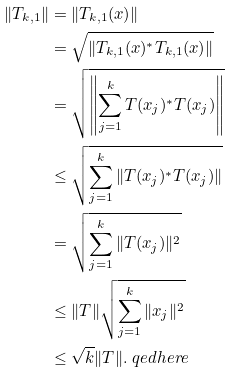Convert formula to latex. <formula><loc_0><loc_0><loc_500><loc_500>\| T _ { k , 1 } \| & = \| T _ { k , 1 } ( x ) \| \\ & = \sqrt { \| T _ { k , 1 } ( x ) ^ { * } T _ { k , 1 } ( x ) \| } \\ & = \sqrt { \left \| \sum _ { j = 1 } ^ { k } T ( x _ { j } ) ^ { * } T ( x _ { j } ) \right \| } \\ & \leq \sqrt { \sum _ { j = 1 } ^ { k } \| T ( x _ { j } ) ^ { * } T ( x _ { j } ) \| } \\ & = \sqrt { \sum _ { j = 1 } ^ { k } \| T ( x _ { j } ) \| ^ { 2 } } \\ & \leq \| T \| \sqrt { \sum _ { j = 1 } ^ { k } \| x _ { j } \| ^ { 2 } } \\ & \leq \sqrt { k } \| T \| . \ q e d h e r e</formula> 